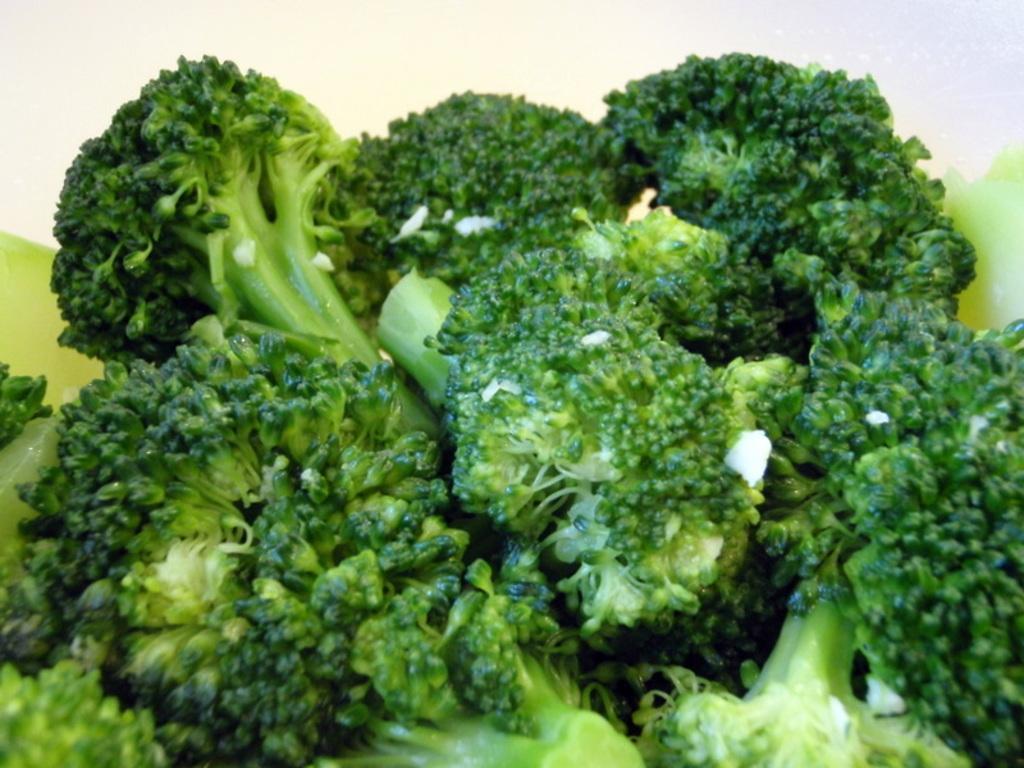Describe this image in one or two sentences. In this image, we can see there are broccoli pieces arranged. And the background is white in color. 